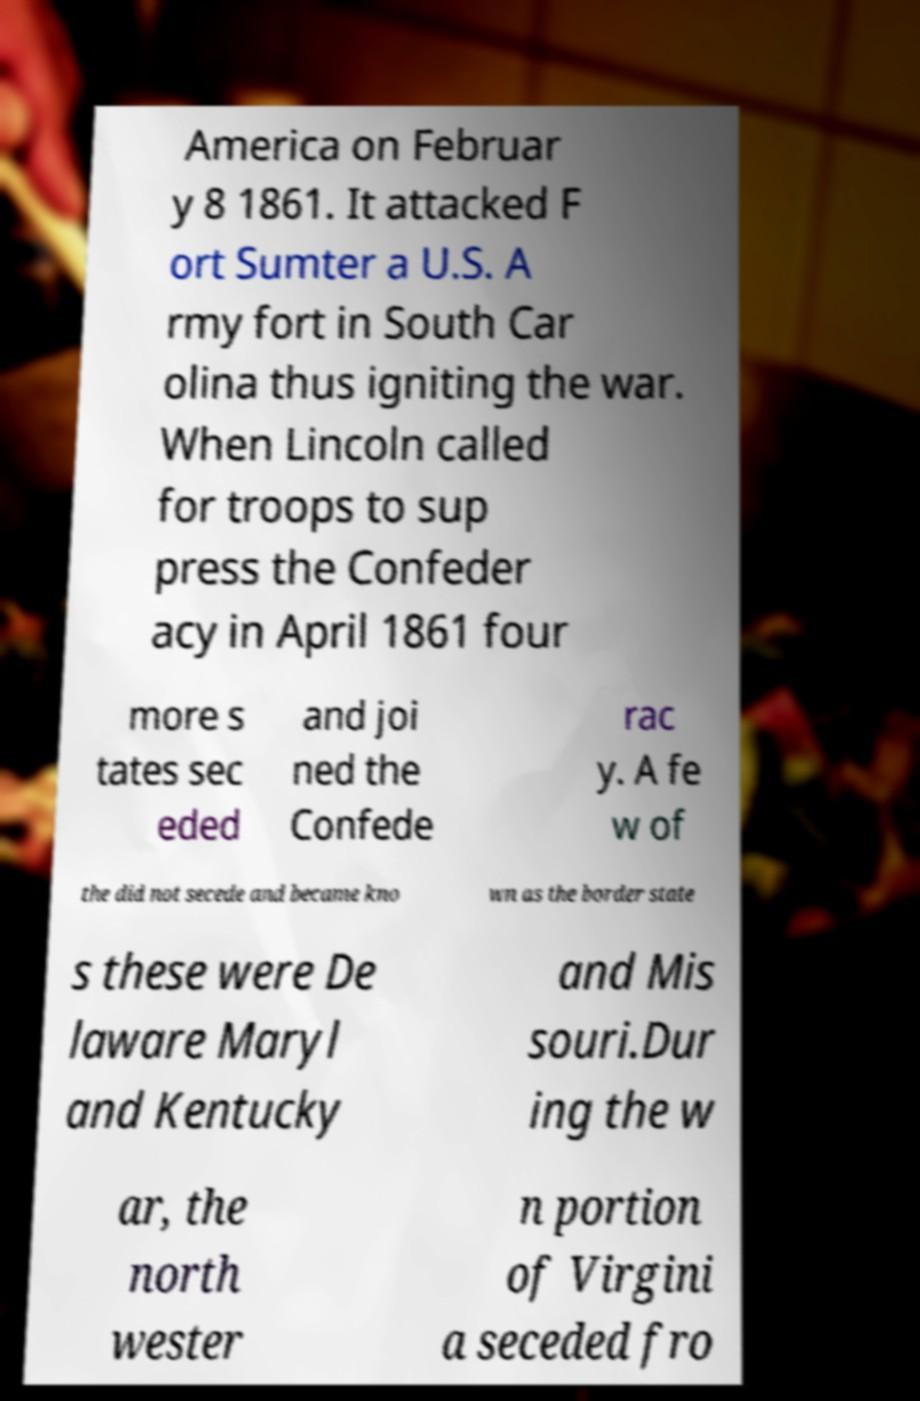Could you assist in decoding the text presented in this image and type it out clearly? America on Februar y 8 1861. It attacked F ort Sumter a U.S. A rmy fort in South Car olina thus igniting the war. When Lincoln called for troops to sup press the Confeder acy in April 1861 four more s tates sec eded and joi ned the Confede rac y. A fe w of the did not secede and became kno wn as the border state s these were De laware Maryl and Kentucky and Mis souri.Dur ing the w ar, the north wester n portion of Virgini a seceded fro 